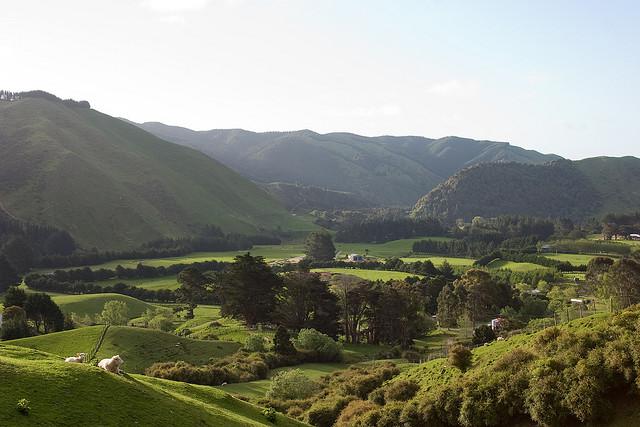Where are the hills?
Short answer required. Background. What kind of animal is on the hill to the left?
Keep it brief. Sheep. How many roads are there?
Answer briefly. 0. 